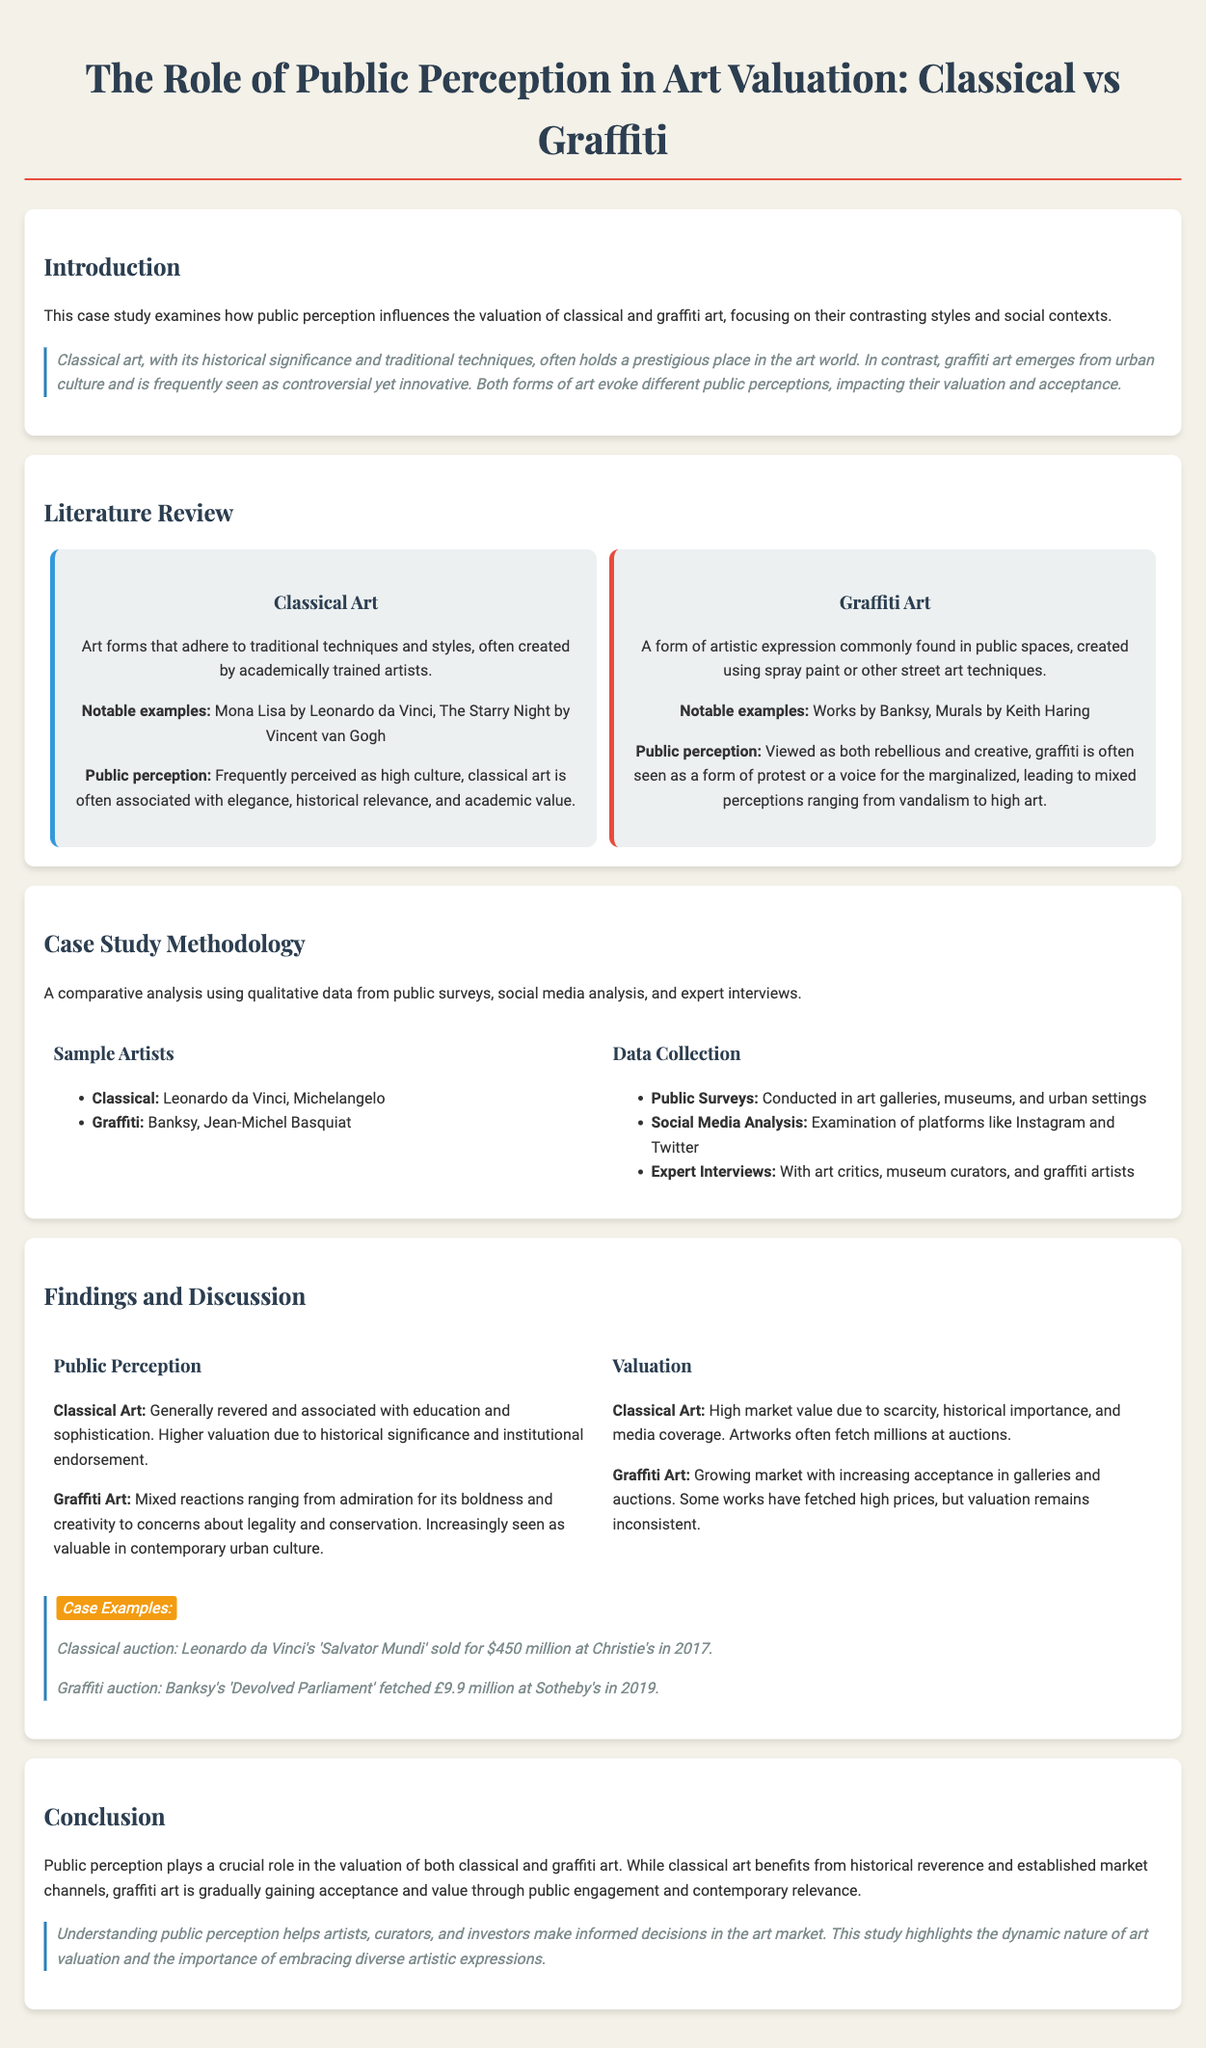What is the title of the case study? The title is prominently displayed at the top of the document, stating the focus of the study.
Answer: The Role of Public Perception in Art Valuation: Classical vs Graffiti Who are two classical artists mentioned? The document lists notable classical artists in the methodology section.
Answer: Leonardo da Vinci, Michelangelo What is a notable graffiti artist mentioned? The methodology section highlights a key figure in graffiti art.
Answer: Banksy What is the highest auction price for a classical artwork stated in the study? The findings section provides specific auction data for classical art.
Answer: $450 million How is graffiti art generally perceived according to the document? The public perception section describes graffiti art's reception in general terms.
Answer: Rebellious and creative Which platforms were analyzed for social media in this study? The paragraph under Data Collection specifies the platforms used for analysis.
Answer: Instagram and Twitter What significant event took place in 2019 regarding a graffiti artwork? The findings section cites a specific auction event for graffiti art.
Answer: Banksy's 'Devolved Parliament' fetched £9.9 million What kind of data was collected in the study? The methodology section describes the types of data collected for analysis.
Answer: Qualitative data What does classical art benefit from according to the conclusion? The conclusion discusses the advantages of classical art in the valuation context.
Answer: Historical reverence 